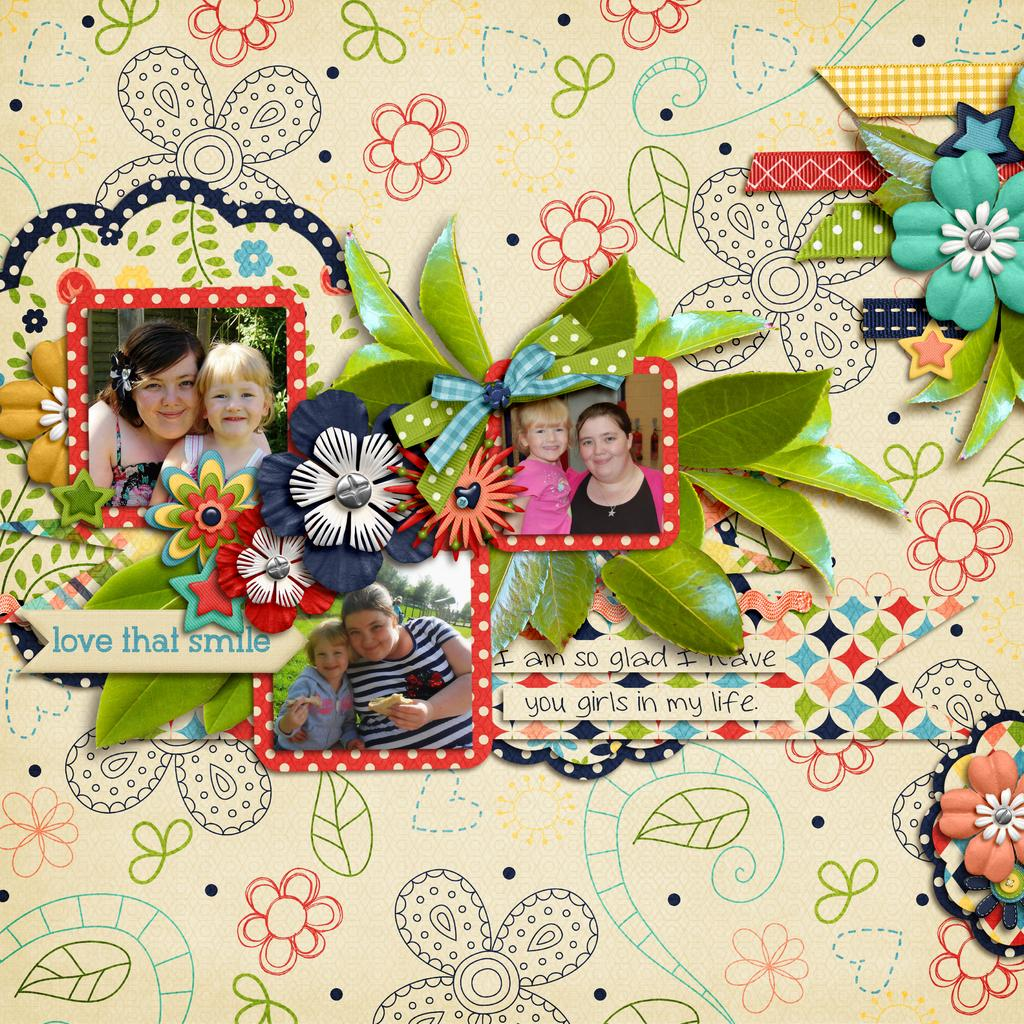What is the main subject of the picture? The main subject of the picture is art work. How many images are included in the art work? The art work consists of three images. What can be said about the materials used in the images? The images are crafted with different materials. How would you describe the quality of the crafting in the images? The crafting is done beautifully. How many ants can be seen carrying balls in the image? There are no ants or balls present in the image; it features art work with three images crafted with different materials. 